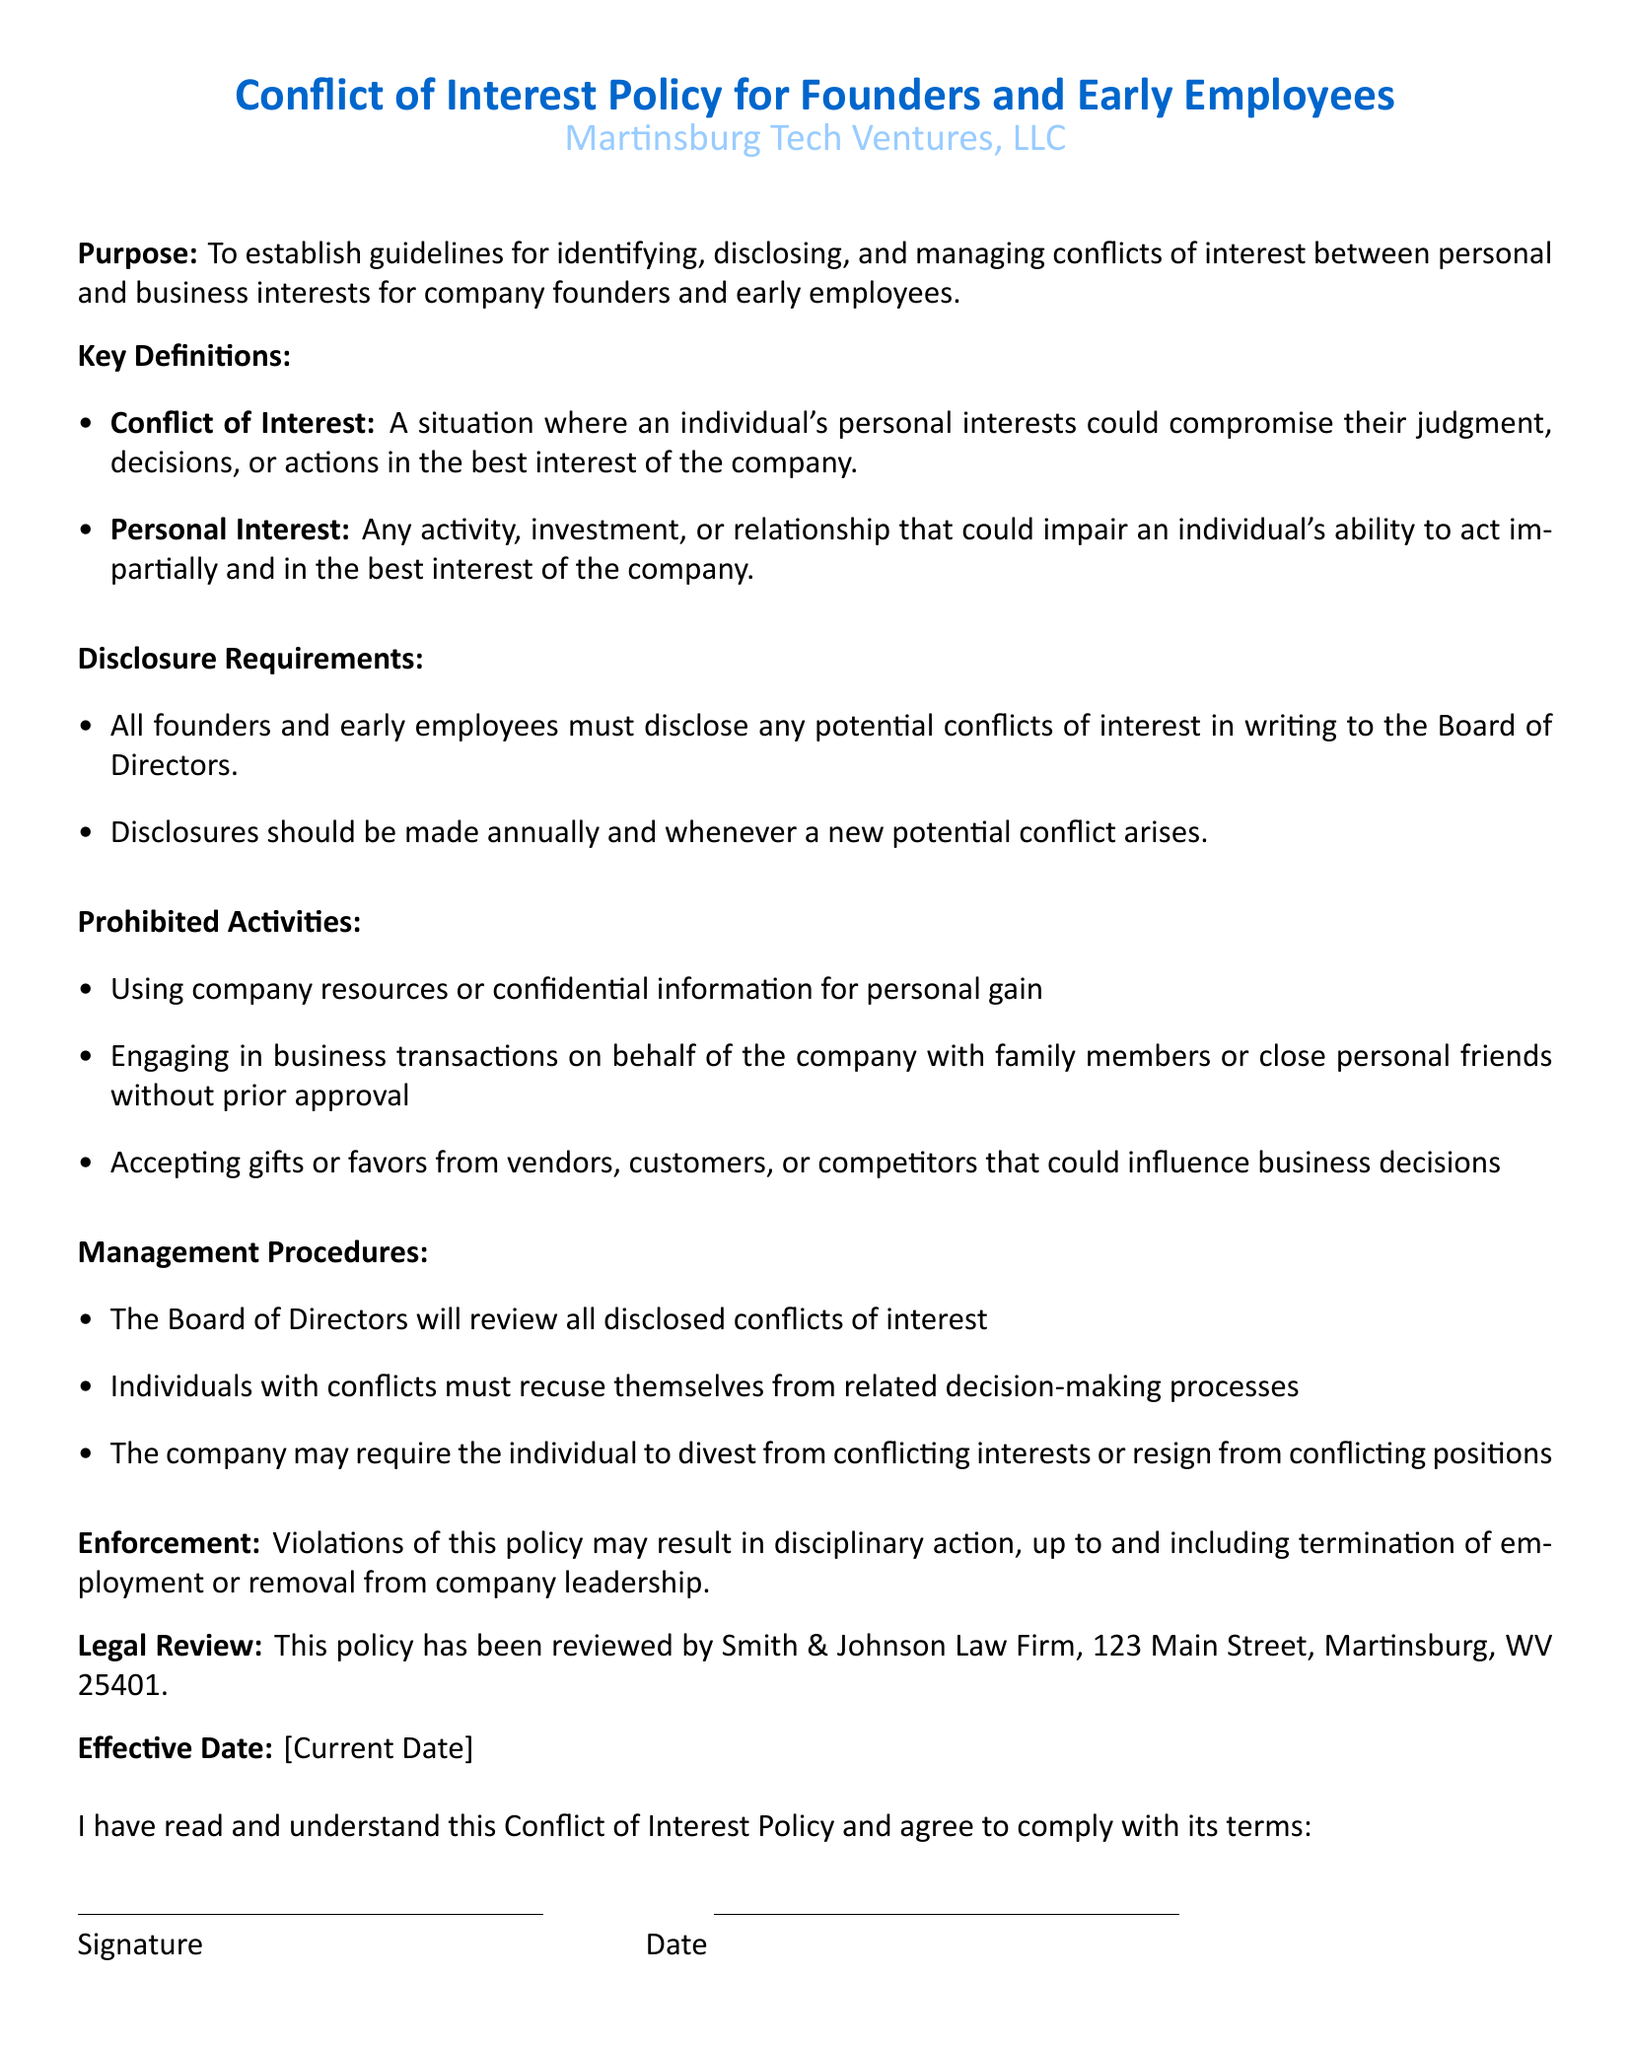What is the purpose of the policy? The policy aims to establish guidelines for identifying, disclosing, and managing conflicts of interest.
Answer: To establish guidelines for identifying, disclosing, and managing conflicts of interest Who must disclose potential conflicts of interest? The policy states that all founders and early employees are required to disclose any potential conflicts.
Answer: All founders and early employees What must disclosures be made in response to? Disclosures should be made annually and whenever a new potential conflict arises.
Answer: Annually and whenever a new potential conflict arises What is one prohibited activity related to this policy? The document lists several prohibited activities, including using company resources for personal gain.
Answer: Using company resources or confidential information for personal gain What action must be taken by individuals with disclosed conflicts? The document states that individuals must recuse themselves from related decision-making processes.
Answer: Recuse themselves from related decision-making processes Who reviews all disclosed conflicts of interest? According to the policy, the Board of Directors is responsible for reviewing disclosed conflicts.
Answer: The Board of Directors What may happen if someone violates the policy? The policy indicates that violations may result in disciplinary actions, including termination.
Answer: Disciplinary action, up to and including termination of employment What law firm reviewed this policy? The document mentions that Smith & Johnson Law Firm reviewed the policy.
Answer: Smith & Johnson Law Firm When is the effective date of the policy? The effective date is marked as the current date, which will be filled at the time of signing.
Answer: [Current Date] 